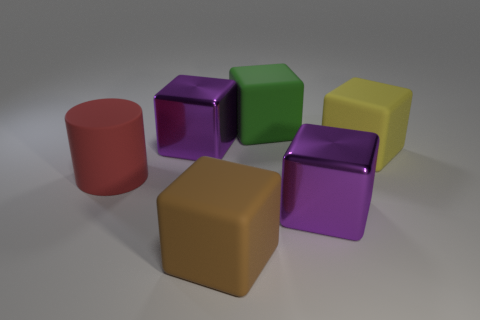What size is the brown cube that is made of the same material as the big yellow block?
Your answer should be compact. Large. How many large brown matte things have the same shape as the large green rubber object?
Offer a very short reply. 1. There is a cylinder that is the same size as the yellow block; what is its material?
Offer a terse response. Rubber. Are there any green things that have the same material as the large brown cube?
Make the answer very short. Yes. There is a matte thing that is both behind the brown block and on the left side of the big green block; what color is it?
Give a very brief answer. Red. What number of other things are the same color as the big matte cylinder?
Ensure brevity in your answer.  0. What material is the yellow cube that is right of the large purple metallic block behind the purple object on the right side of the green matte block?
Give a very brief answer. Rubber. What number of blocks are either red things or big purple shiny objects?
Give a very brief answer. 2. Are there any other things that have the same size as the rubber cylinder?
Keep it short and to the point. Yes. How many large purple metallic cubes are behind the purple object in front of the big metal cube behind the cylinder?
Your response must be concise. 1. 